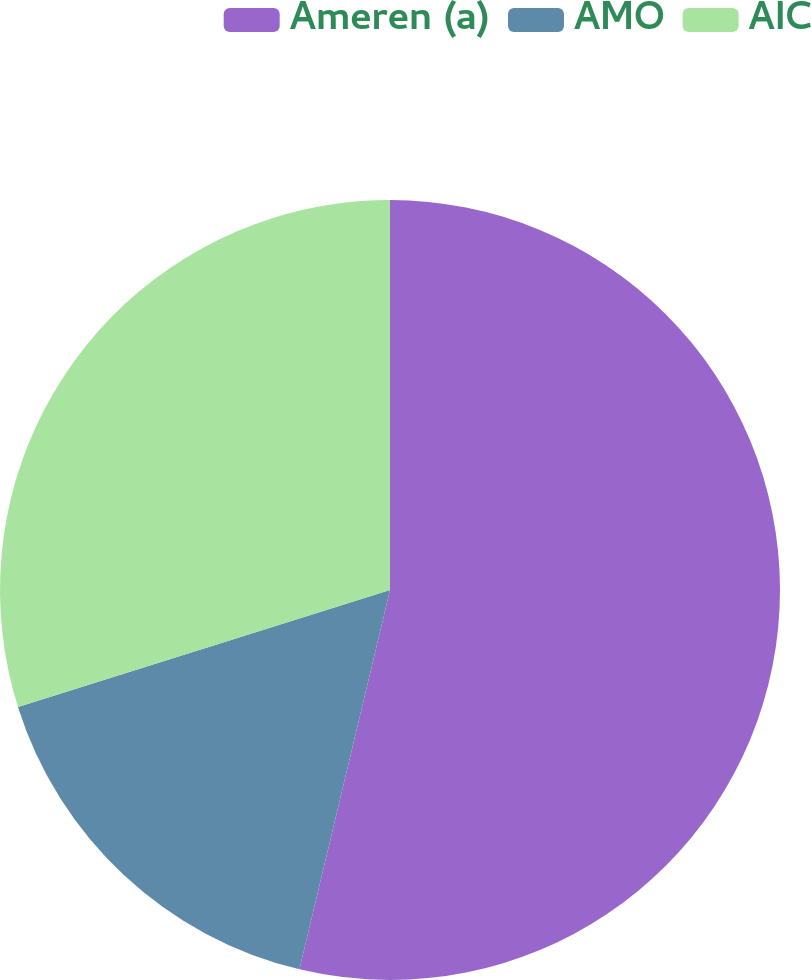Convert chart to OTSL. <chart><loc_0><loc_0><loc_500><loc_500><pie_chart><fcel>Ameren (a)<fcel>AMO<fcel>AIC<nl><fcel>53.73%<fcel>16.42%<fcel>29.85%<nl></chart> 